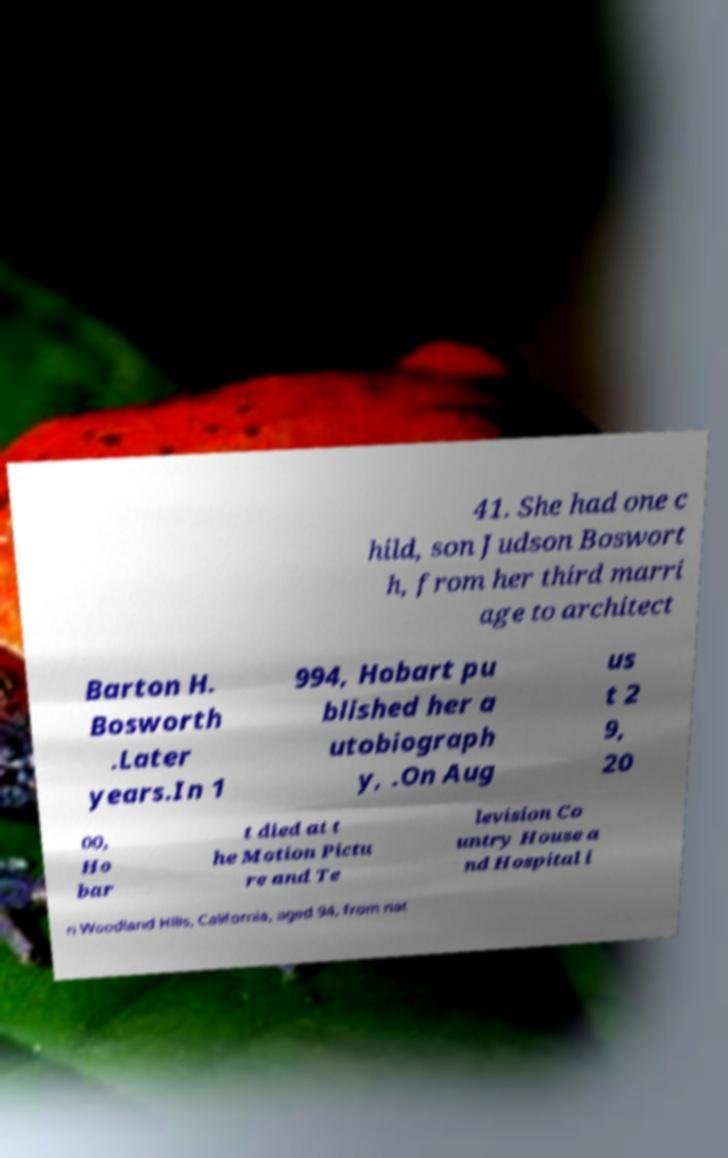Please read and relay the text visible in this image. What does it say? 41. She had one c hild, son Judson Boswort h, from her third marri age to architect Barton H. Bosworth .Later years.In 1 994, Hobart pu blished her a utobiograph y, .On Aug us t 2 9, 20 00, Ho bar t died at t he Motion Pictu re and Te levision Co untry House a nd Hospital i n Woodland Hills, California, aged 94, from nat 